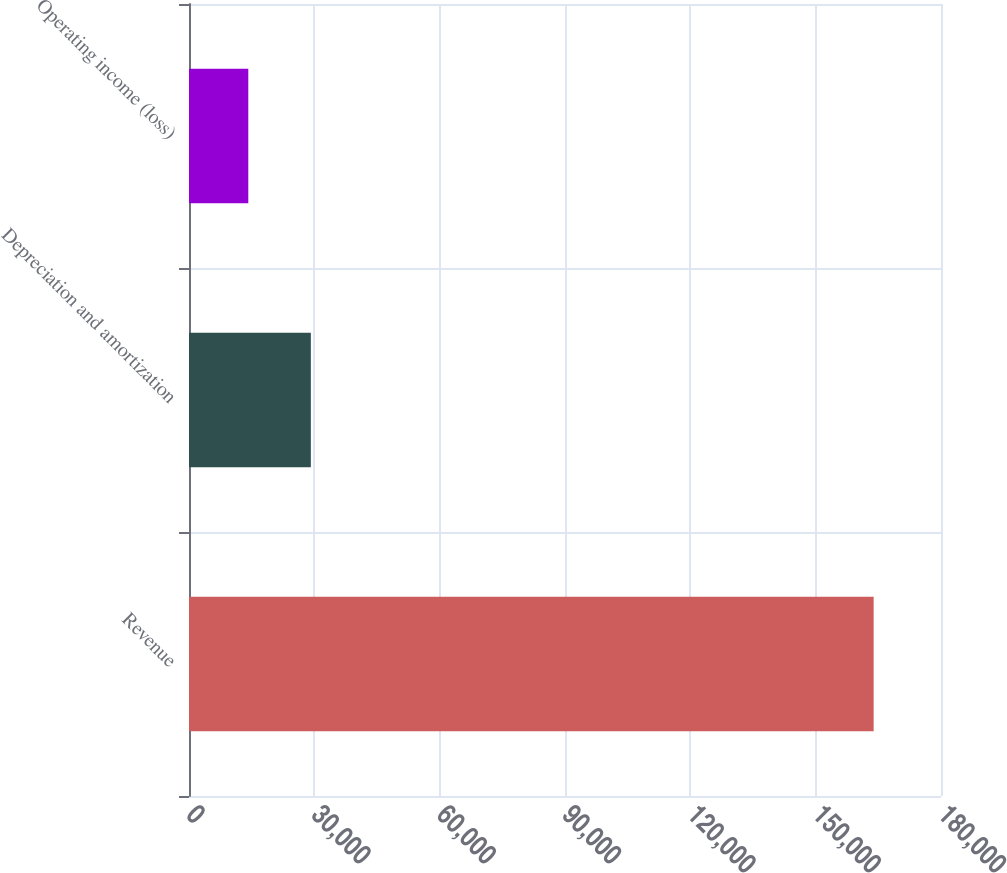Convert chart. <chart><loc_0><loc_0><loc_500><loc_500><bar_chart><fcel>Revenue<fcel>Depreciation and amortization<fcel>Operating income (loss)<nl><fcel>163878<fcel>29163.3<fcel>14195<nl></chart> 